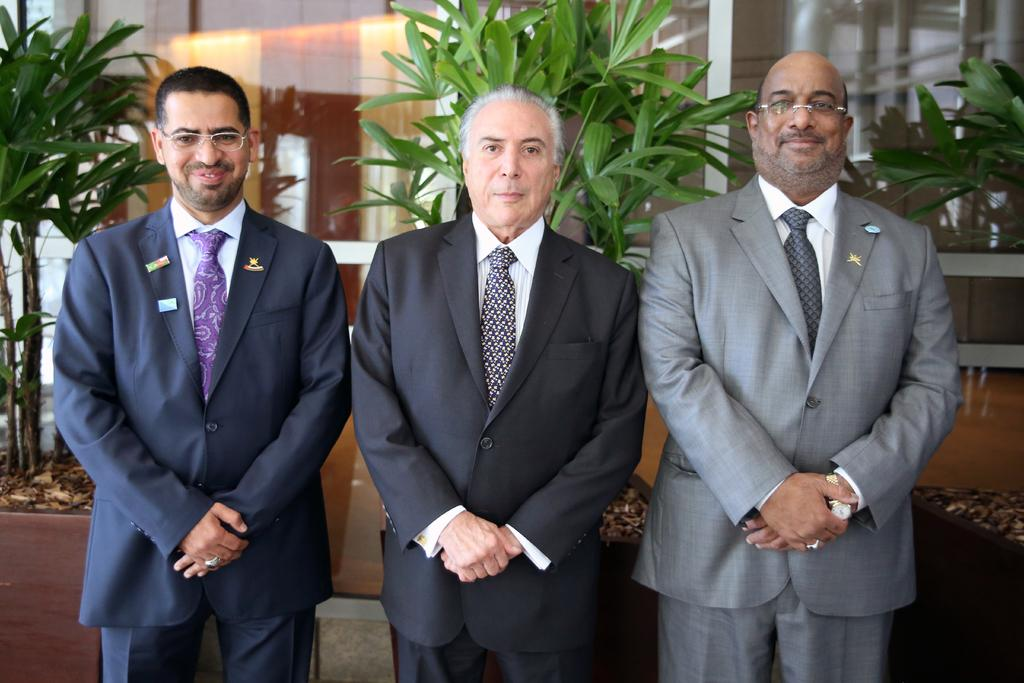How many people are present in the image? There are three people standing in the image. What can be seen in the background of the image? Plants are visible in the background of the image. What type of hose is being used to water the plants in the image? There is no hose present in the image; only the people and plants are visible. 